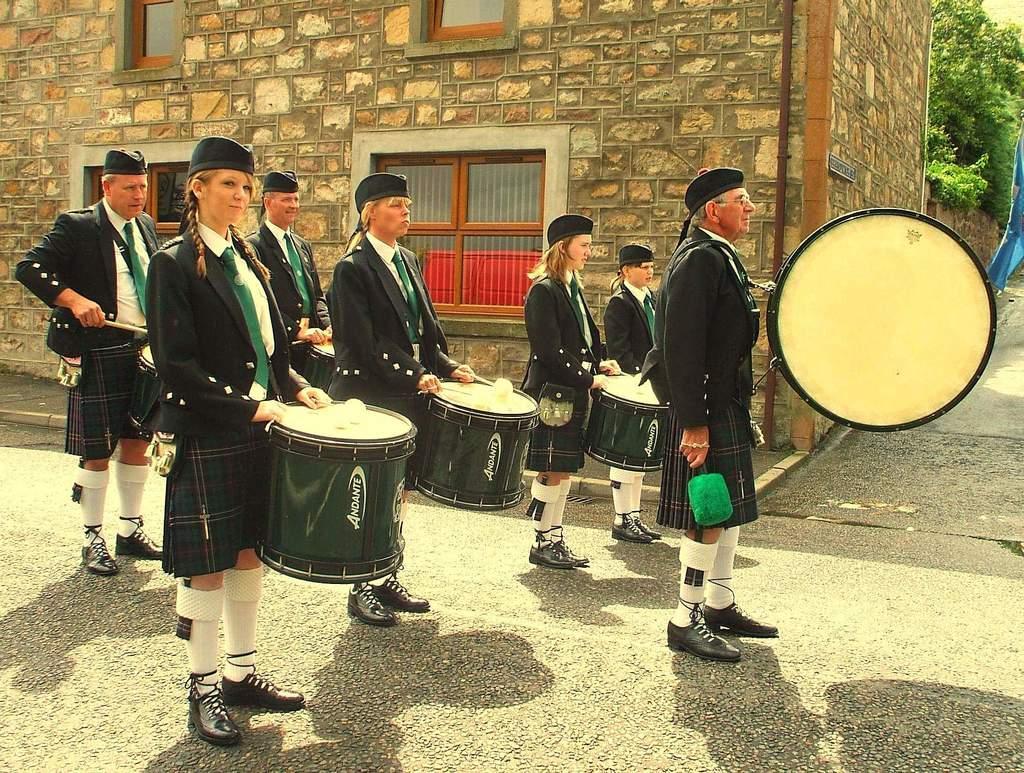Describe this image in one or two sentences. These are seven persons standing on the road, playing drums and wearing black color suit, tie and skirt. In the background, there is a building having widows. Beside this, there are trees. 